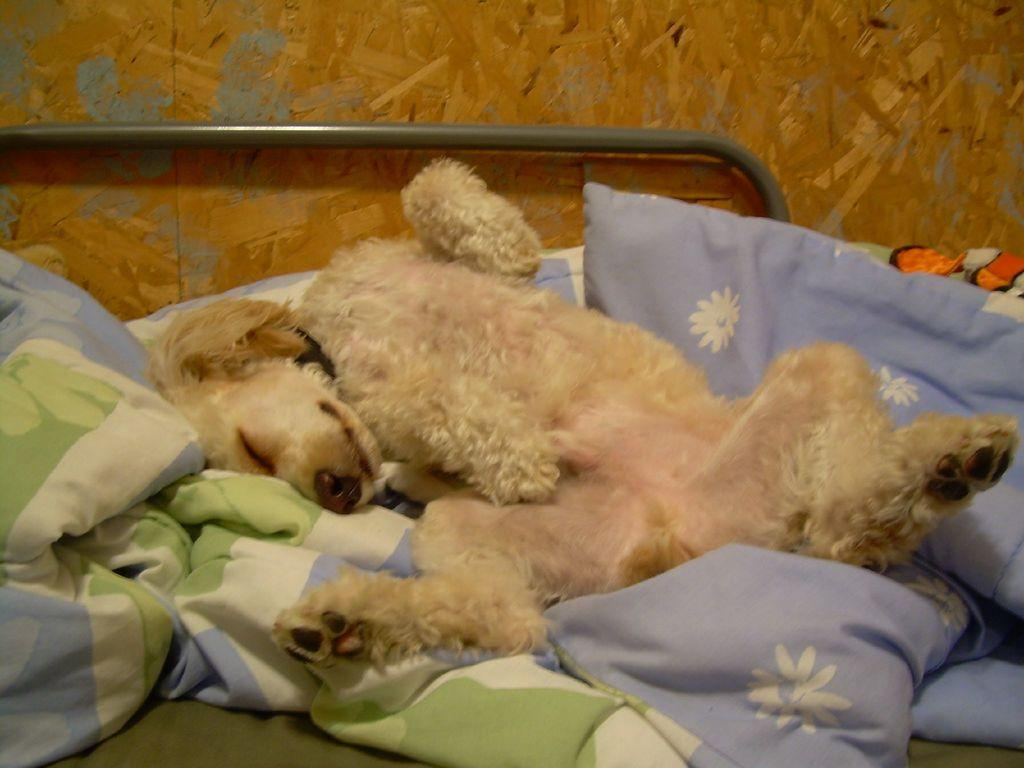What is lying on the bed in the image? There is a dog lying on the bed. What is the dog lying on? The dog is on bed sheets. Are there any additional features on the bed? Yes, the bed has pillows. What can be seen in the background of the image? There is a wall in the image. How many geese are flying with their wings spread in the image? There are no geese present in the image. What type of profit can be seen in the image? There is no profit visible in the image. 